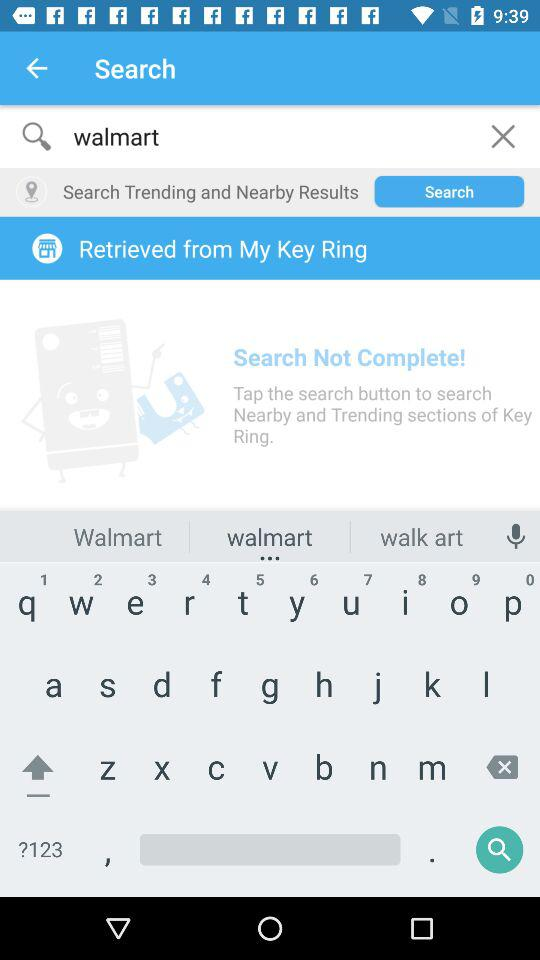What is the email address? The email address is appcrawler4@gmail.com. 